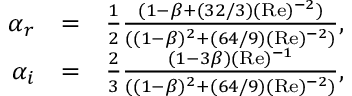<formula> <loc_0><loc_0><loc_500><loc_500>\begin{array} { r l r } { \alpha _ { r } } & { = } & { \frac { 1 } { 2 } \frac { ( 1 - \beta + ( 3 2 / 3 ) ( R e ) ^ { - 2 } ) } { ( ( 1 - \beta ) ^ { 2 } + ( 6 4 / 9 ) ( R e ) ^ { - 2 } ) } , } \\ { \alpha _ { i } } & { = } & { \frac { 2 } { 3 } \frac { ( 1 - 3 \beta ) ( R e ) ^ { - 1 } } { ( ( 1 - \beta ) ^ { 2 } + ( 6 4 / 9 ) ( R e ) ^ { - 2 } ) } , } \end{array}</formula> 